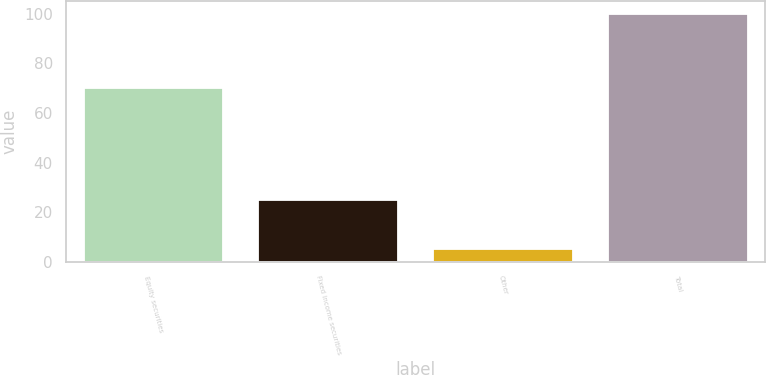<chart> <loc_0><loc_0><loc_500><loc_500><bar_chart><fcel>Equity securities<fcel>Fixed income securities<fcel>Other<fcel>Total<nl><fcel>70<fcel>25<fcel>5<fcel>100<nl></chart> 